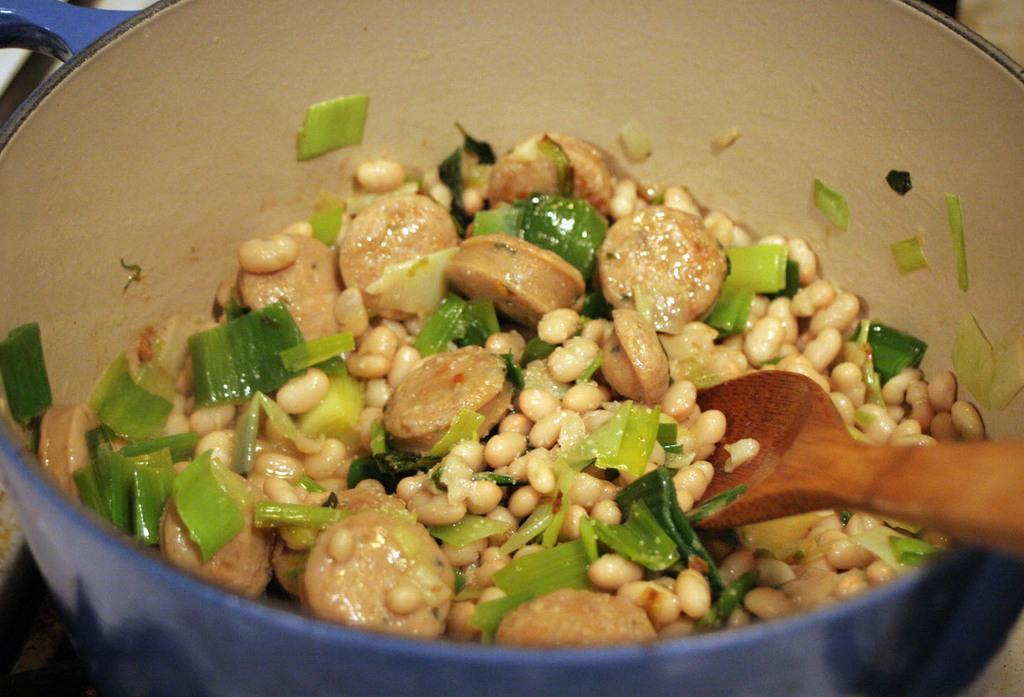What is the main subject of the image? There is a food item in the image. What utensil is present in the image? There is a spoon in the image. Where are the food item and spoon located? The food item and spoon are in a bowl. How is the bowl positioned in the image? The bowl is in the center of the image. What type of star can be seen fueling the light in the image? There is no star or light present in the image; it features a bowl with a food item and a spoon. 